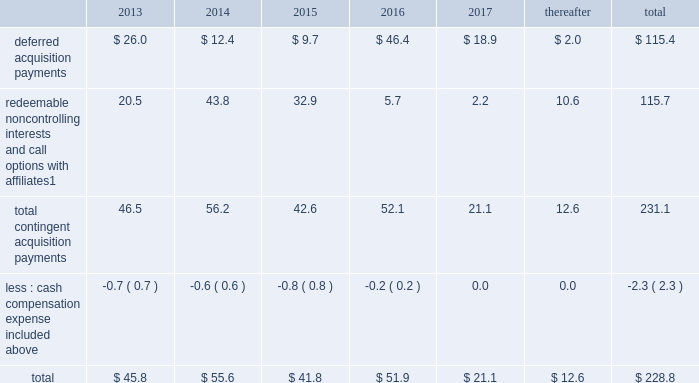Notes to consolidated financial statements 2013 ( continued ) ( amounts in millions , except per share amounts ) guarantees we have guaranteed certain obligations of our subsidiaries relating principally to operating leases and credit facilities of certain subsidiaries .
The amount of parent company guarantees on lease obligations was $ 410.3 and $ 385.1 as of december 31 , 2012 and 2011 , respectively , and the amount of parent company guarantees primarily relating to credit facilities was $ 283.4 and $ 327.5 as of december 31 , 2012 and 2011 , respectively .
In the event of non-payment by the applicable subsidiary of the obligations covered by a guarantee , we would be obligated to pay the amounts covered by that guarantee .
As of december 31 , 2012 , there were no material assets pledged as security for such parent company guarantees .
Contingent acquisition obligations the table details the estimated future contingent acquisition obligations payable in cash as of december 31 .
1 we have entered into certain acquisitions that contain both redeemable noncontrolling interests and call options with similar terms and conditions .
We have certain redeemable noncontrolling interests that are exercisable at the discretion of the noncontrolling equity owners as of december 31 , 2012 .
These estimated payments of $ 16.4 are included within the total payments expected to be made in 2013 , and will continue to be carried forward into 2014 or beyond until exercised or expired .
Redeemable noncontrolling interests are included in the table at current exercise price payable in cash , not at applicable redemption value in accordance with the authoritative guidance for classification and measurement of redeemable securities .
The estimated amounts listed would be paid in the event of exercise at the earliest exercise date .
See note 6 for further information relating to the payment structure of our acquisitions .
All payments are contingent upon achieving projected operating performance targets and satisfying other conditions specified in the related agreements and are subject to revisions as the earn-out periods progress .
Legal matters we are involved in various legal proceedings , and subject to investigations , inspections , audits , inquiries and similar actions by governmental authorities , arising in the normal course of business .
We evaluate all cases each reporting period and record liabilities for losses from legal proceedings when we determine that it is probable that the outcome in a legal proceeding will be unfavorable and the amount , or potential range , of loss can be reasonably estimated .
In certain cases , we cannot reasonably estimate the potential loss because , for example , the litigation is in its early stages .
While any outcome related to litigation or such governmental proceedings in which we are involved cannot be predicted with certainty , management believes that the outcome of these matters , individually and in the aggregate , will not have a material adverse effect on our financial condition , results of operations or cash flows .
Note 15 : recent accounting standards impairment of indefinite-lived intangible assets in july 2012 , the financial accounting standards board ( 201cfasb 201d ) issued amended guidance to simplify impairment testing of indefinite-lived intangible assets other than goodwill .
The amended guidance permits an entity to first assess qualitative factors to determine whether it is 201cmore likely than not 201d that the indefinite-lived intangible asset is impaired .
If , after assessing qualitative factors , an entity concludes that it is not 201cmore likely than not 201d that the indefinite-lived intangible .
What is the mathematical range for tedeemable noncontrolling interests and call options with affiliates from 2013-2017? 
Computations: (46.4 - 9.7)
Answer: 36.7. 